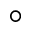Convert formula to latex. <formula><loc_0><loc_0><loc_500><loc_500>^ { \circ }</formula> 